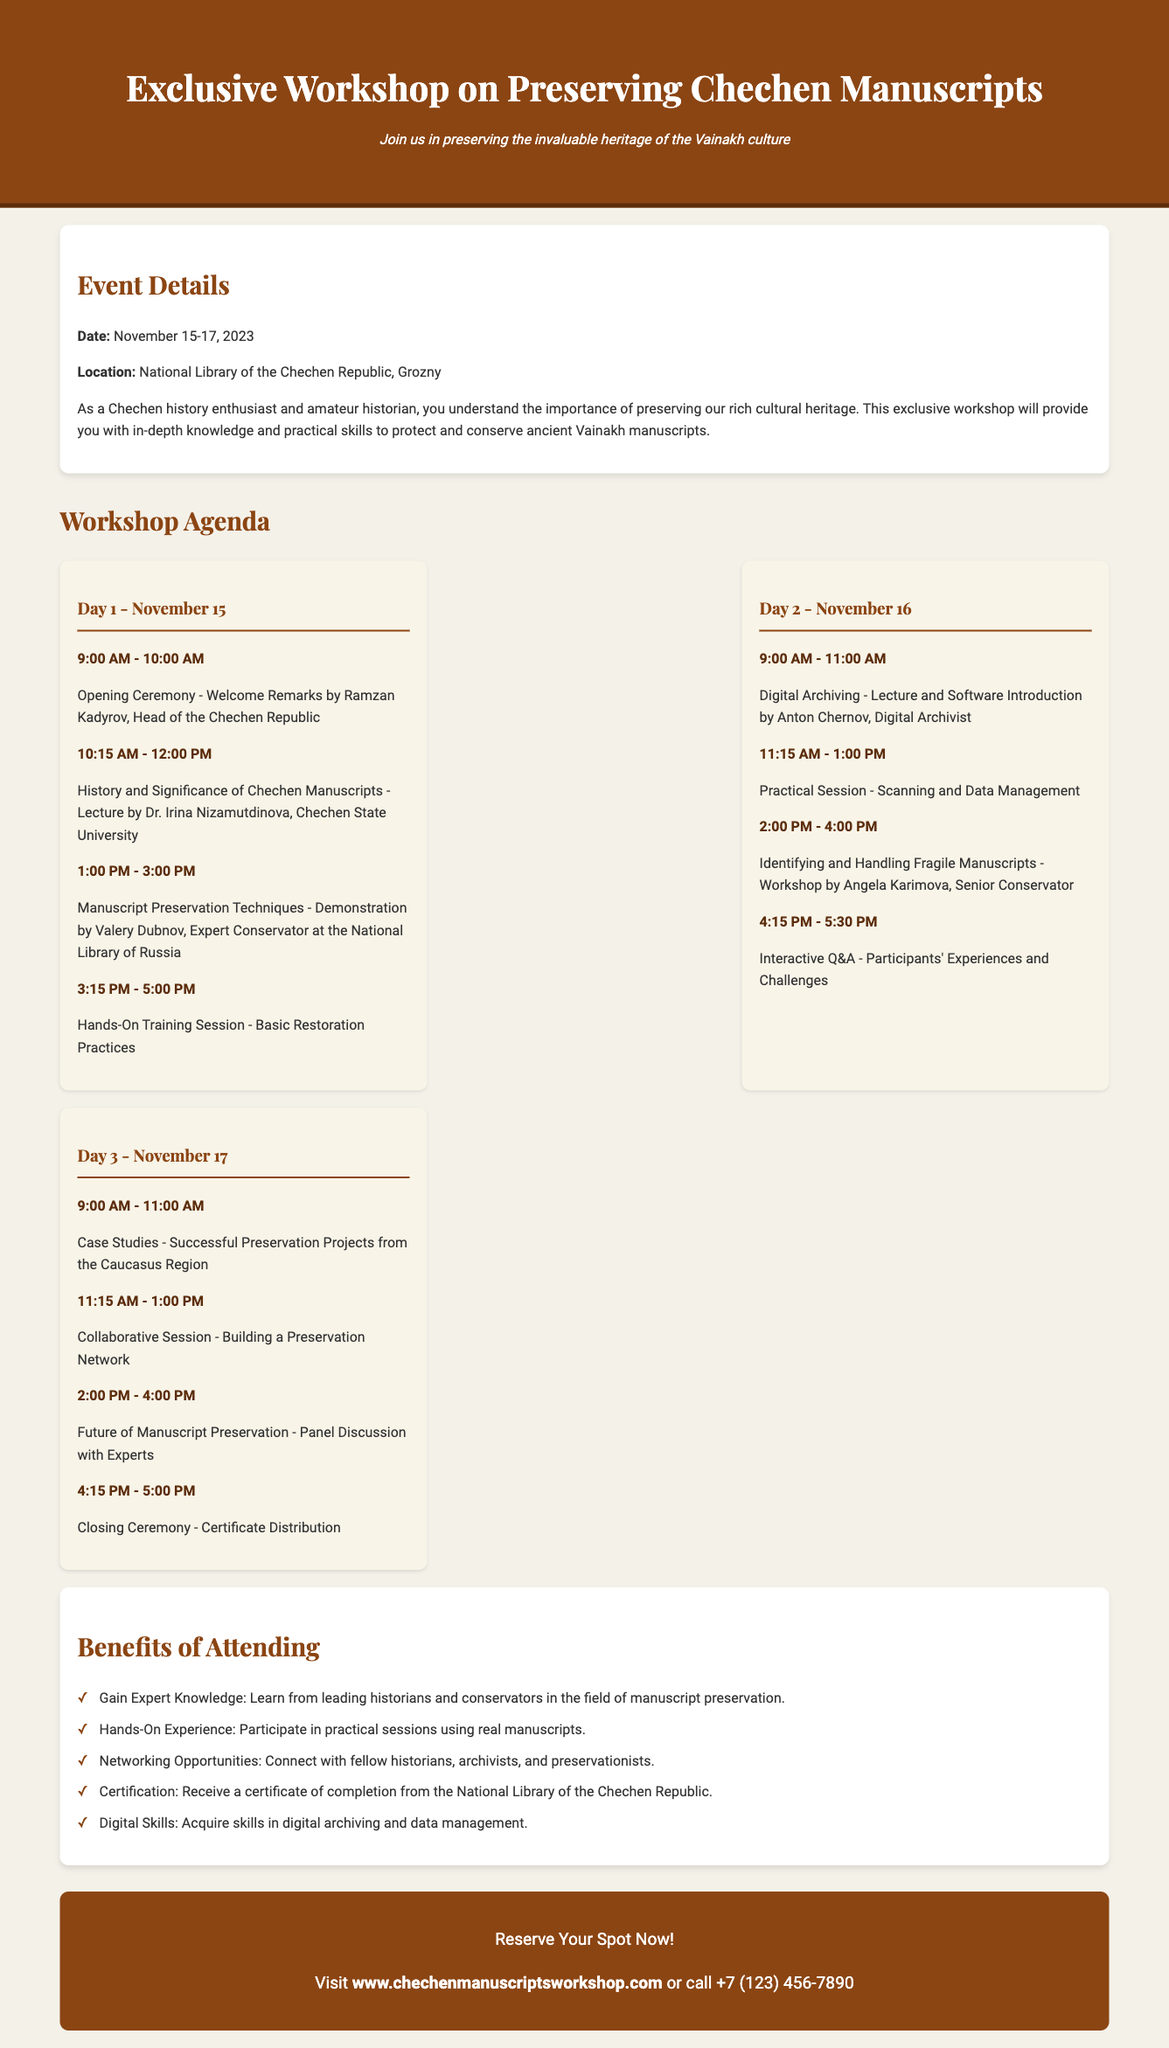What are the dates of the workshop? The dates of the workshop are explicitly mentioned in the document as November 15-17, 2023.
Answer: November 15-17, 2023 Who is the opening ceremony speaker? The document provides the name of the speaker during the opening ceremony as Ramzan Kadyrov.
Answer: Ramzan Kadyrov What is the location of the workshop? The location is specified in the event details as the National Library of the Chechen Republic, Grozny.
Answer: National Library of the Chechen Republic, Grozny What type of certification will participants receive? The document indicates that participants will receive a certificate of completion from the National Library of the Chechen Republic.
Answer: Certificate of completion Which day has a session on digital archiving? A closer look at the agenda reveals that the session on digital archiving is scheduled for Day 2, November 16.
Answer: Day 2, November 16 What is the focus of the Q&A session? The document states that the focus of the interactive Q&A on Day 2 is on participants' experiences and challenges.
Answer: Participants' experiences and challenges Which expert is leading the session on manuscript preservation techniques? The session on manuscript preservation techniques is led by Valery Dubnov, as indicated in the agenda.
Answer: Valery Dubnov What benefits are outlined for attending? The benefits include gaining expert knowledge, hands-on experience, networking opportunities, certification, and digital skills as listed in the document.
Answer: Gain Expert Knowledge, Hands-On Experience, Networking Opportunities, Certification, Digital Skills What is the website for reserving a spot? The document provides the website link for reserving a spot as www.chechenmanuscriptsworkshop.com.
Answer: www.chechenmanuscriptsworkshop.com 